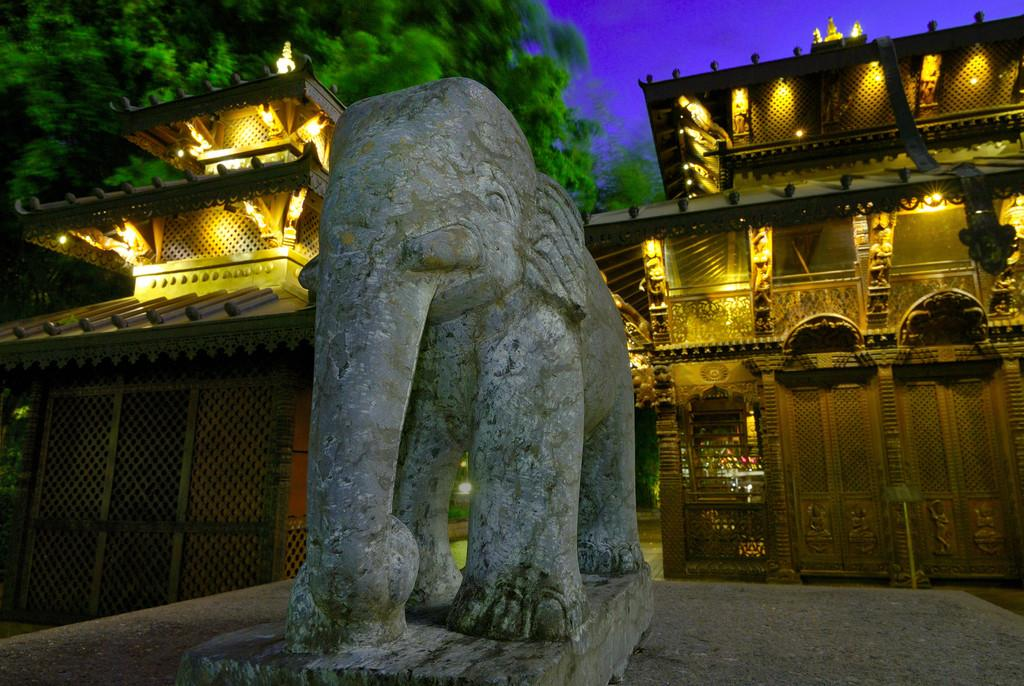What is the main subject of the image? There is a statue in the image. What can be seen in the background of the image? Buildings, lights, trees, and the sky are visible in the background of the image. How would you describe the sky in the image? The sky appears cloudy in the image. What type of temper does the crook have in the image? There is no crook present in the image, so it is not possible to determine their temper. 